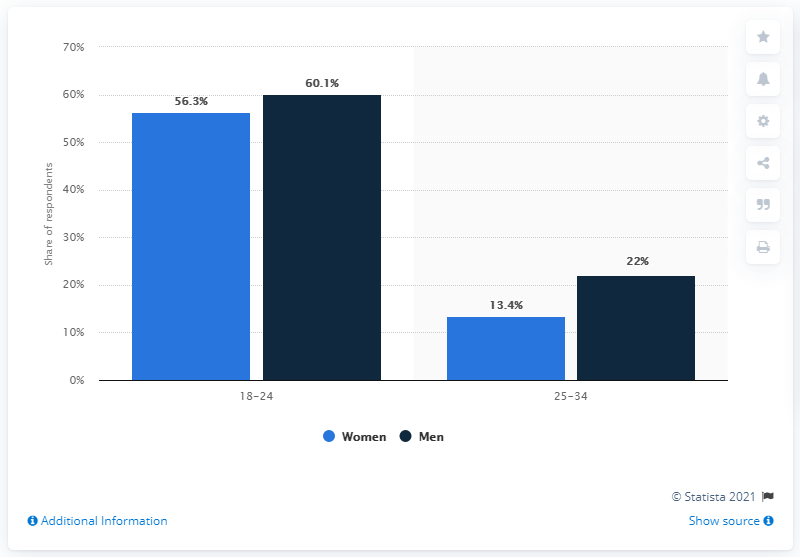Give some essential details in this illustration. A significant percentage of men lived in their parents' home in 2022. 